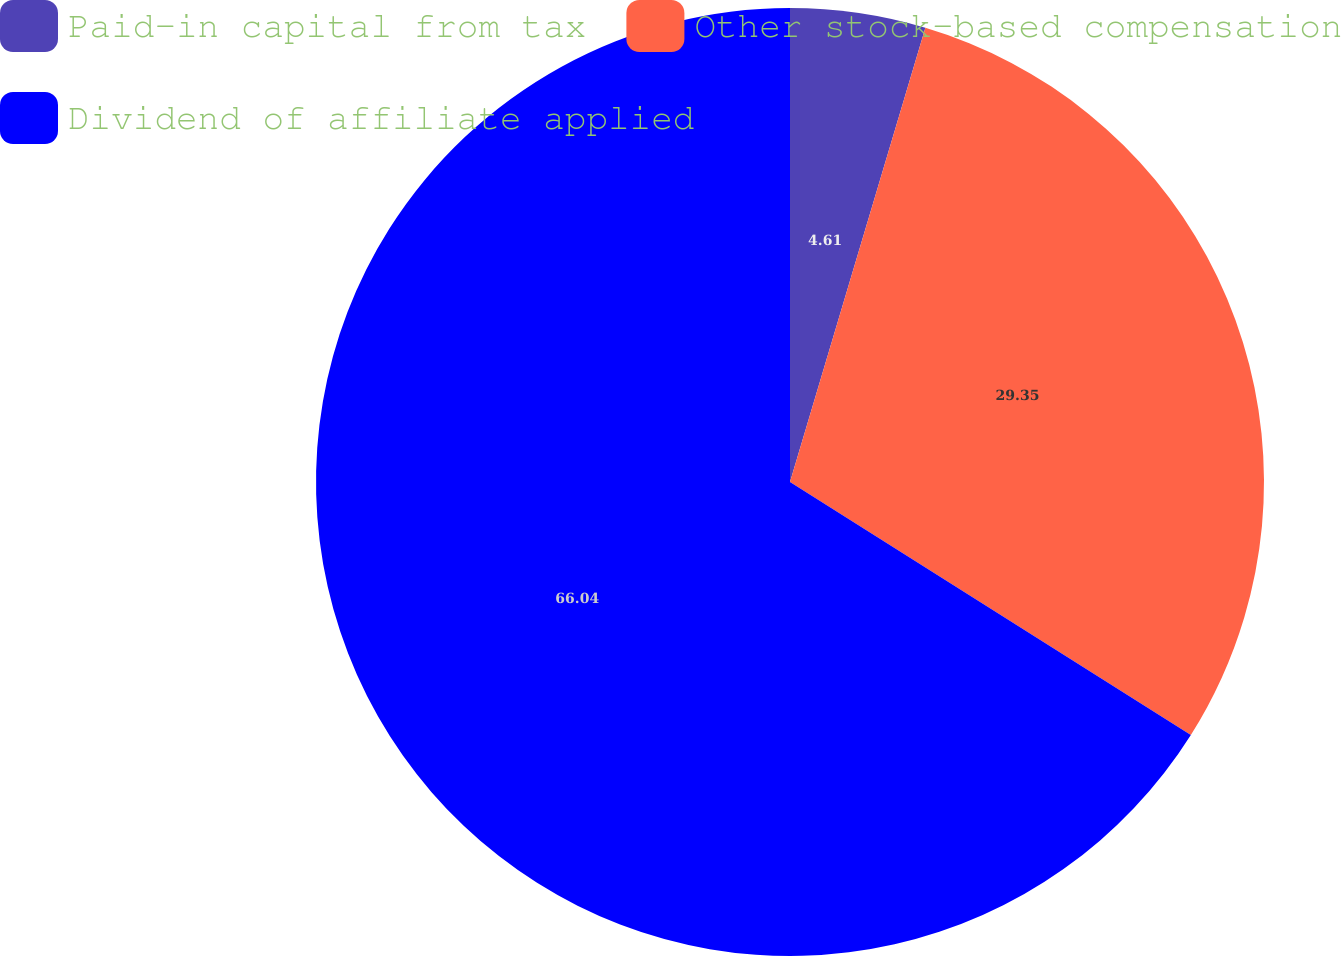Convert chart to OTSL. <chart><loc_0><loc_0><loc_500><loc_500><pie_chart><fcel>Paid-in capital from tax<fcel>Other stock-based compensation<fcel>Dividend of affiliate applied<nl><fcel>4.61%<fcel>29.35%<fcel>66.04%<nl></chart> 